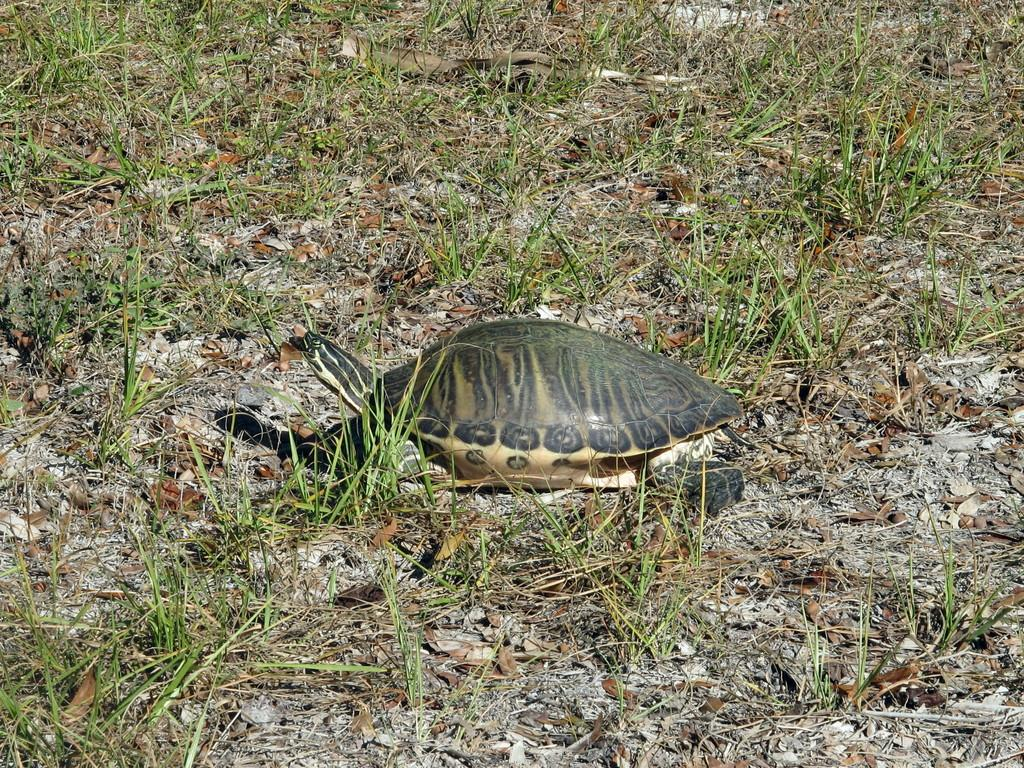What is the main subject in the middle of the image? There is a tortoise in the middle of the image. What type of natural environment is visible behind the tortoise? There is grass visible behind the tortoise. What type of oven can be seen in the image? There is no oven present in the image; it features a tortoise and grass. Is there a note attached to the tortoise in the image? There is no note attached to the tortoise in the image. 